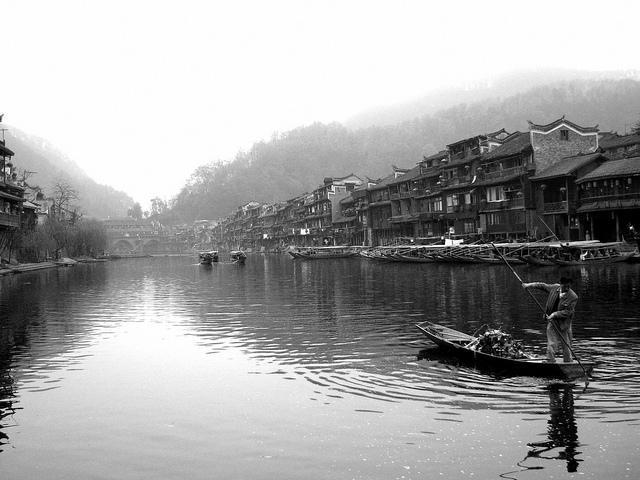Which type action propels the nearest boat forward?
Answer the question by selecting the correct answer among the 4 following choices and explain your choice with a short sentence. The answer should be formatted with the following format: `Answer: choice
Rationale: rationale.`
Options: Poking, motor, none, rowing. Answer: poking.
Rationale: In shallow waters with shallow punts such as this, poles are used to stab the bottom of the river to propel it along. 